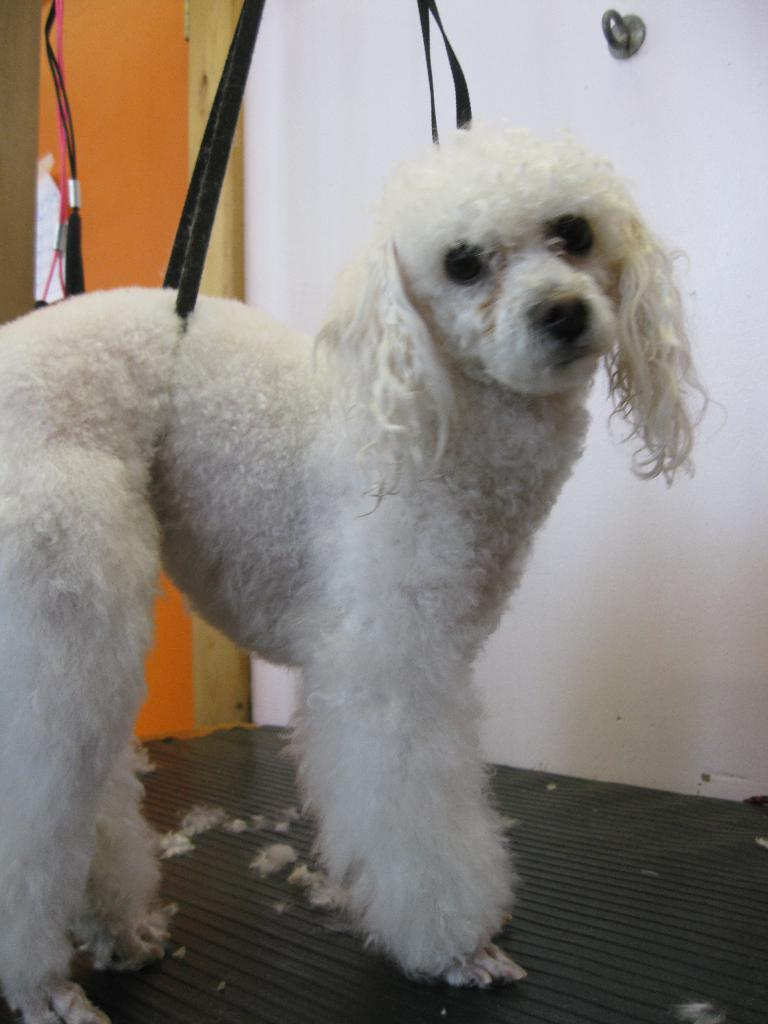What type of animal is in the image? There is a dog in the image. What can be seen on the left side of the image? There are objects on the left side of the image. What feature of the dog is visible in the image? The dog's hairs are visible in the image. What type of accessory is present in the image? There is a belt in the image. What type of agreement is being discussed in the image? There is no discussion or agreement present in the image; it features a dog and other objects. What type of yak can be seen grazing in the background of the image? There is no yak present in the image; it only features a dog and other objects. 